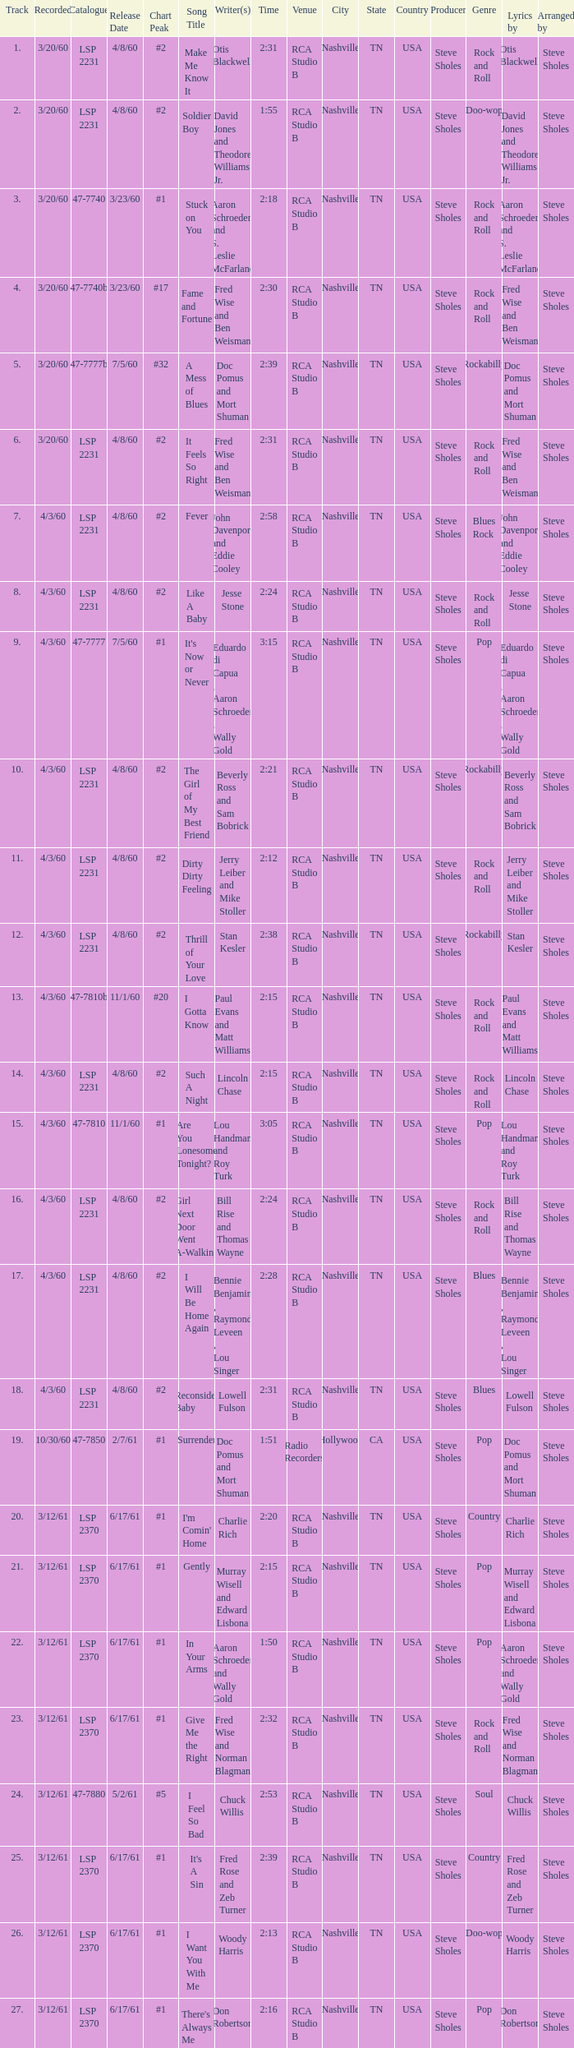For songs with a release date of 6/17/61, a track exceeding 20, and composed by woody harris, what is the highest chart position? #1. 